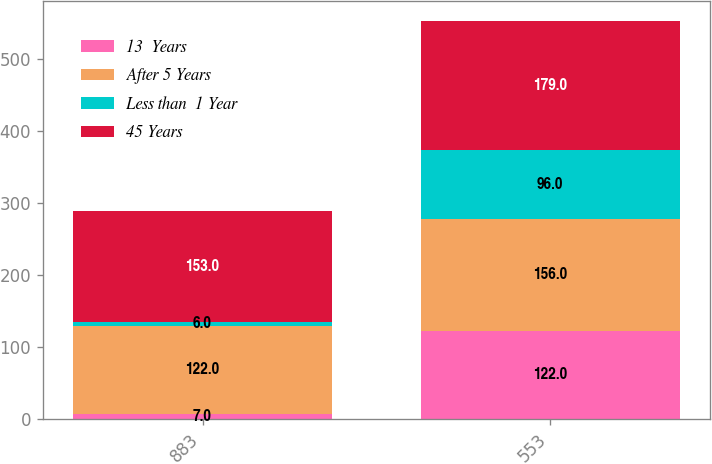<chart> <loc_0><loc_0><loc_500><loc_500><stacked_bar_chart><ecel><fcel>883<fcel>553<nl><fcel>13  Years<fcel>7<fcel>122<nl><fcel>After 5 Years<fcel>122<fcel>156<nl><fcel>Less than  1 Year<fcel>6<fcel>96<nl><fcel>45 Years<fcel>153<fcel>179<nl></chart> 